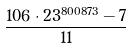Convert formula to latex. <formula><loc_0><loc_0><loc_500><loc_500>\frac { 1 0 6 \cdot 2 3 ^ { 8 0 0 8 7 3 } - 7 } { 1 1 }</formula> 